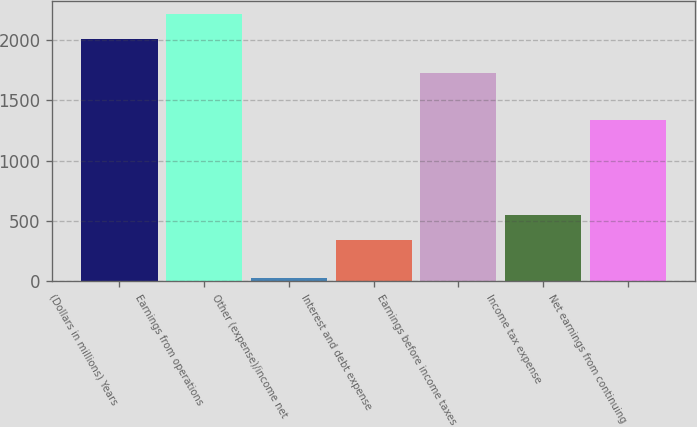<chart> <loc_0><loc_0><loc_500><loc_500><bar_chart><fcel>(Dollars in millions) Years<fcel>Earnings from operations<fcel>Other (expense)/income net<fcel>Interest and debt expense<fcel>Earnings before income taxes<fcel>Income tax expense<fcel>Net earnings from continuing<nl><fcel>2009<fcel>2216<fcel>26<fcel>339<fcel>1731<fcel>546<fcel>1335<nl></chart> 